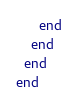Convert code to text. <code><loc_0><loc_0><loc_500><loc_500><_Ruby_>      end
    end
  end
end
</code> 